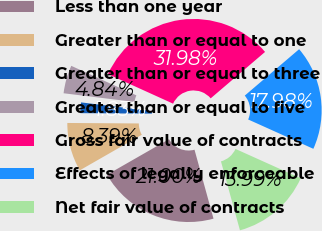Convert chart. <chart><loc_0><loc_0><loc_500><loc_500><pie_chart><fcel>Less than one year<fcel>Greater than or equal to one<fcel>Greater than or equal to three<fcel>Greater than or equal to five<fcel>Gross fair value of contracts<fcel>Effects of legally enforceable<fcel>Net fair value of contracts<nl><fcel>21.0%<fcel>8.39%<fcel>1.83%<fcel>4.84%<fcel>31.98%<fcel>17.98%<fcel>13.99%<nl></chart> 